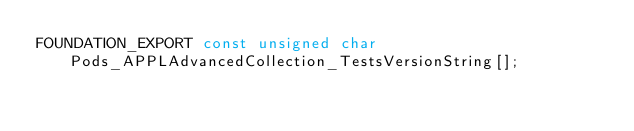Convert code to text. <code><loc_0><loc_0><loc_500><loc_500><_C_>FOUNDATION_EXPORT const unsigned char Pods_APPLAdvancedCollection_TestsVersionString[];

</code> 